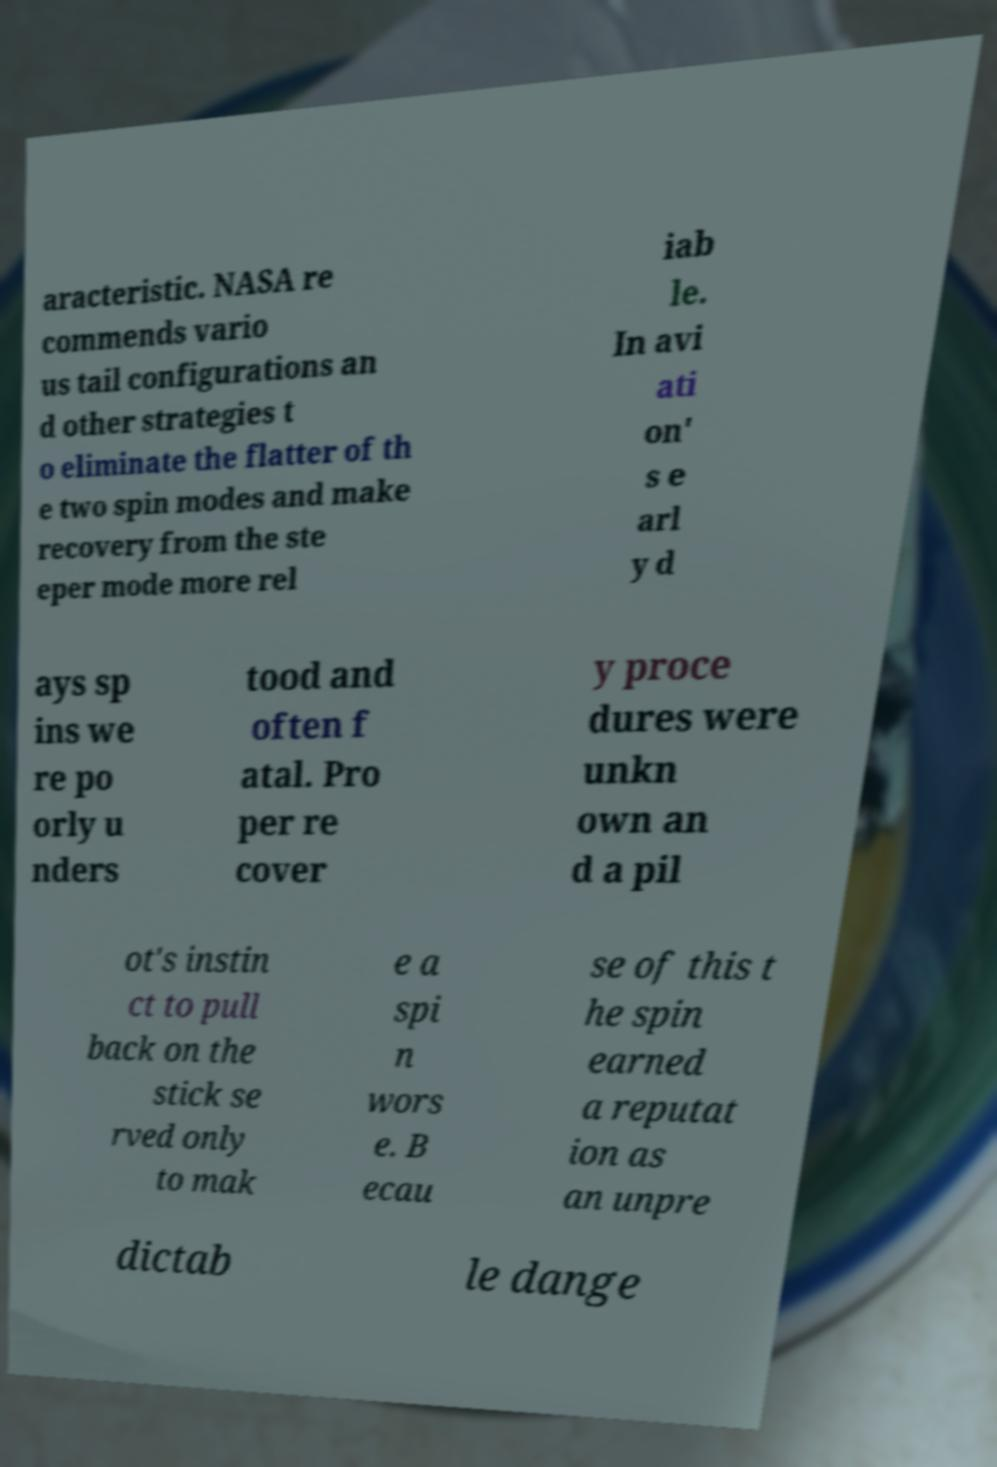Could you assist in decoding the text presented in this image and type it out clearly? aracteristic. NASA re commends vario us tail configurations an d other strategies t o eliminate the flatter of th e two spin modes and make recovery from the ste eper mode more rel iab le. In avi ati on' s e arl y d ays sp ins we re po orly u nders tood and often f atal. Pro per re cover y proce dures were unkn own an d a pil ot's instin ct to pull back on the stick se rved only to mak e a spi n wors e. B ecau se of this t he spin earned a reputat ion as an unpre dictab le dange 